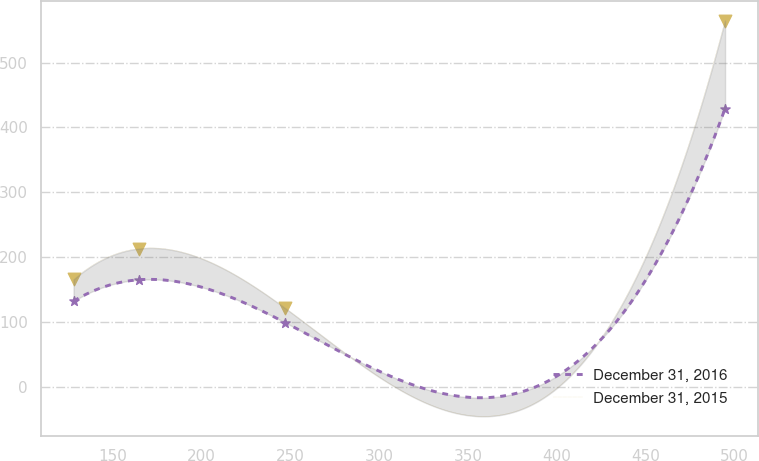Convert chart to OTSL. <chart><loc_0><loc_0><loc_500><loc_500><line_chart><ecel><fcel>December 31, 2016<fcel>December 31, 2015<nl><fcel>127.97<fcel>132.42<fcel>165.95<nl><fcel>164.64<fcel>165.38<fcel>213.38<nl><fcel>247.07<fcel>99.46<fcel>121.64<nl><fcel>494.64<fcel>429.09<fcel>564.74<nl></chart> 